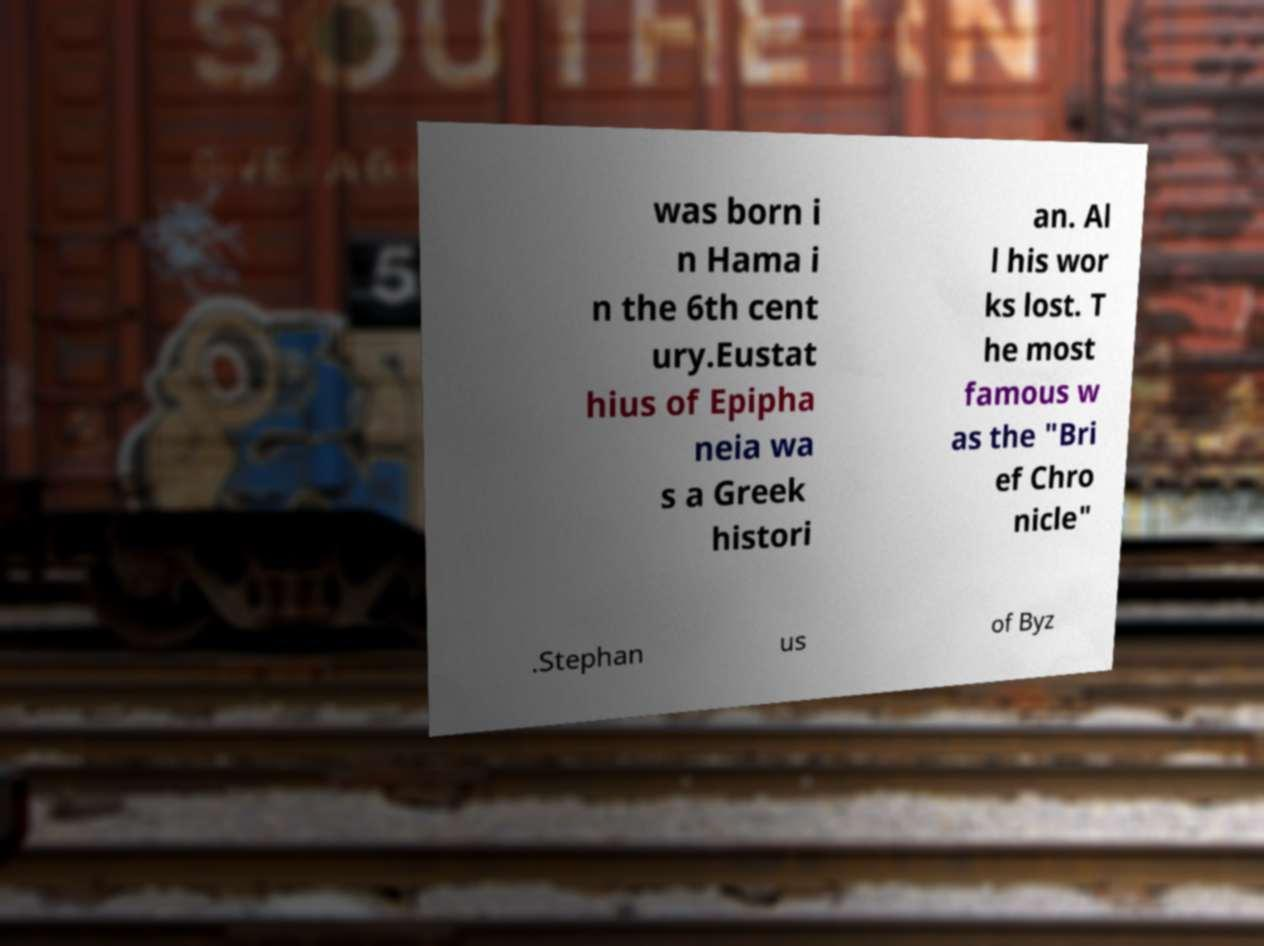Could you extract and type out the text from this image? was born i n Hama i n the 6th cent ury.Eustat hius of Epipha neia wa s a Greek histori an. Al l his wor ks lost. T he most famous w as the "Bri ef Chro nicle" .Stephan us of Byz 